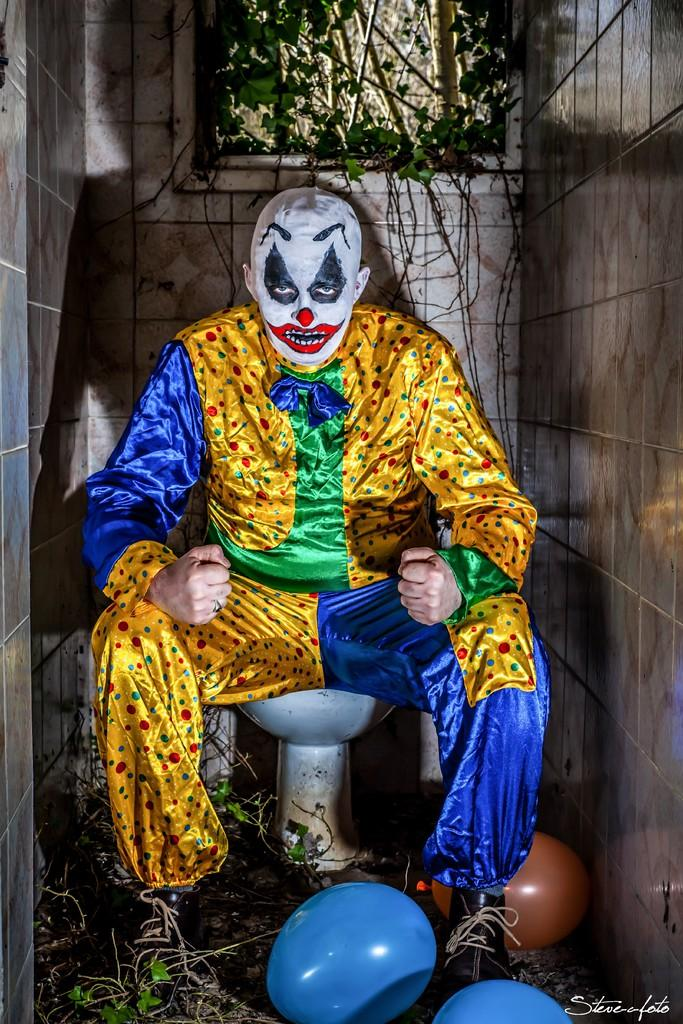What is the man doing in the image? The man is seated on the toilet seat in the image. What else can be seen in the image besides the man? There are balloons and trees in the image. How is the man dressed in the image? The man is wearing a dress with yellow, green, and blue colors. What is on the man's face in the image? The man has painting on his face. What is the beginner's reaction to the camp in the image? There is no camp or beginner mentioned in the image, so it's not possible to answer that question. 